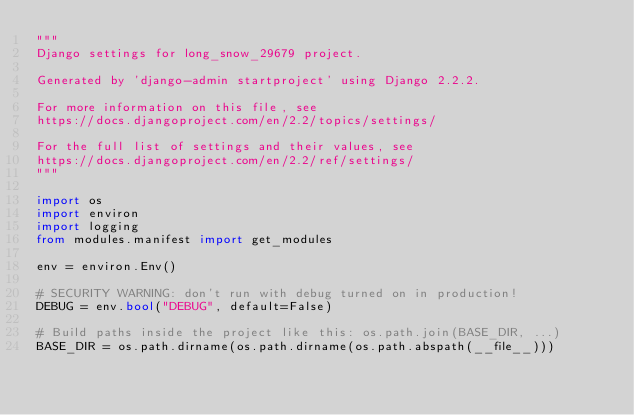Convert code to text. <code><loc_0><loc_0><loc_500><loc_500><_Python_>"""
Django settings for long_snow_29679 project.

Generated by 'django-admin startproject' using Django 2.2.2.

For more information on this file, see
https://docs.djangoproject.com/en/2.2/topics/settings/

For the full list of settings and their values, see
https://docs.djangoproject.com/en/2.2/ref/settings/
"""

import os
import environ
import logging
from modules.manifest import get_modules

env = environ.Env()

# SECURITY WARNING: don't run with debug turned on in production!
DEBUG = env.bool("DEBUG", default=False)

# Build paths inside the project like this: os.path.join(BASE_DIR, ...)
BASE_DIR = os.path.dirname(os.path.dirname(os.path.abspath(__file__)))

</code> 